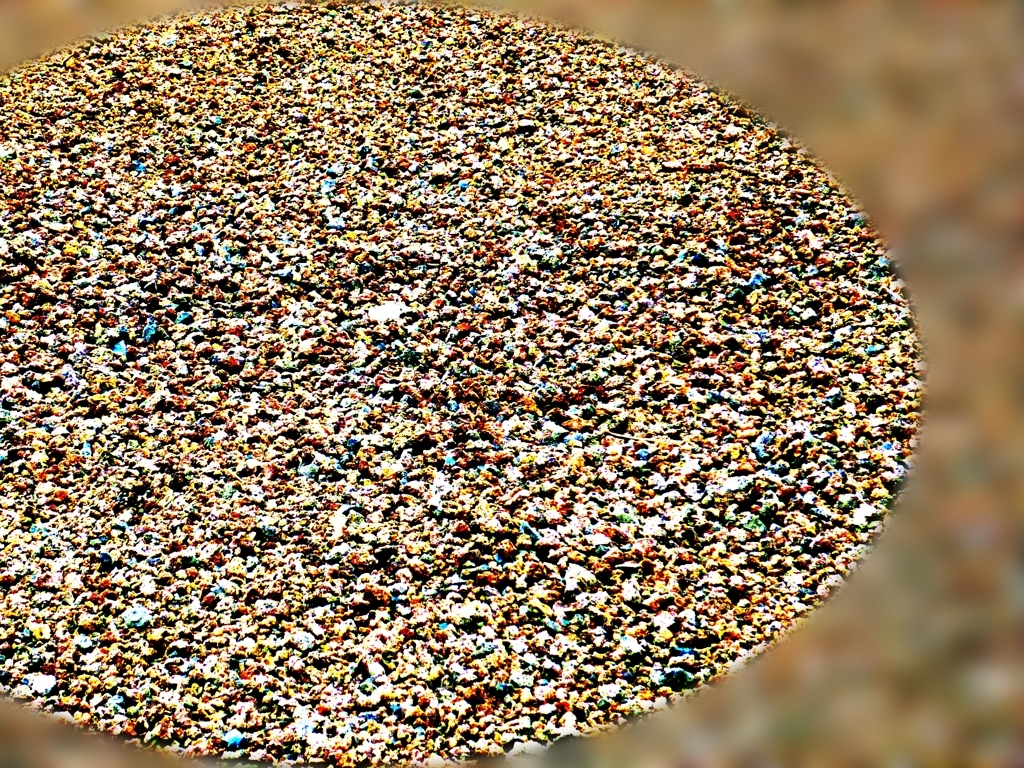What is the image depicting? The image is an abstract depiction that could be interpreted in various ways. It seems to show a multitude of small particles or objects, creating a textured and dynamic visual effect akin to a pointillist painting. 